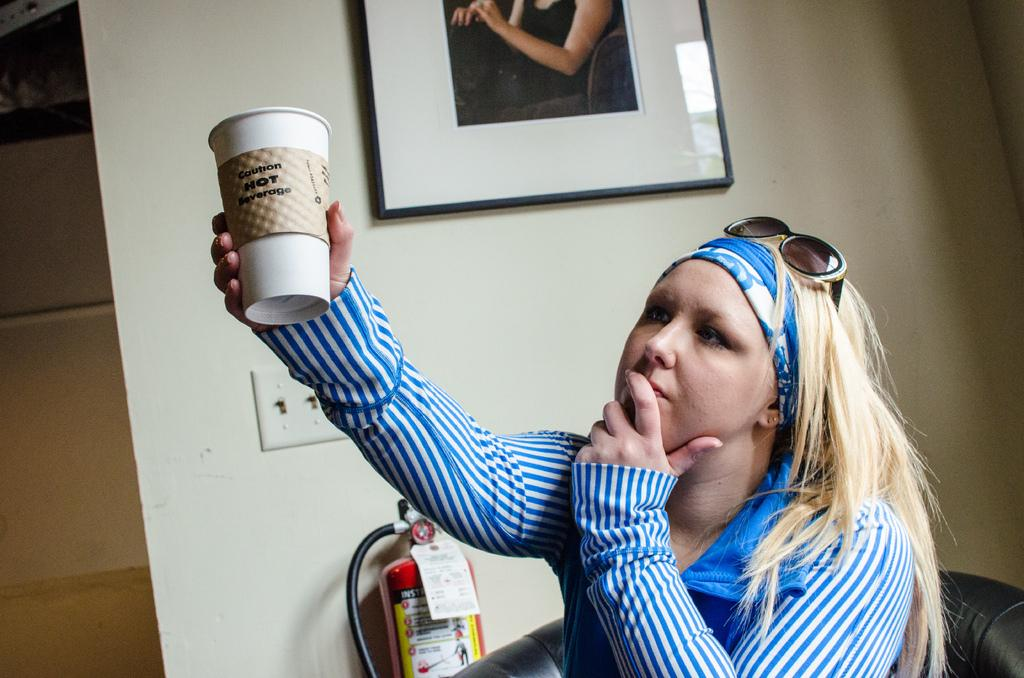What is the person in the image holding? The person is holding a cup. What can be seen in the background of the image? There is a wall in the background of the image. What objects are on the wall? There is a photo frame and a fire extinguisher on the wall. What type of skirt can be seen on the person in the image? There is no skirt visible in the image, as the person is not wearing one. Can you see any boats in the image? There are no boats present in the image. 